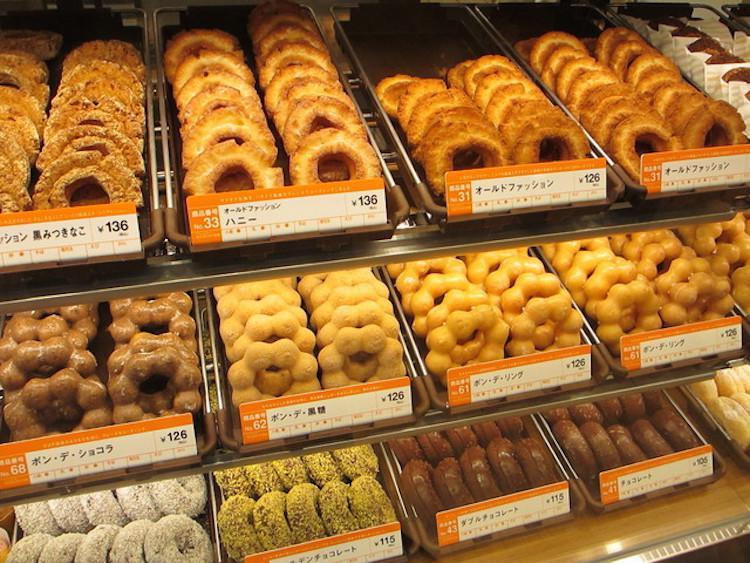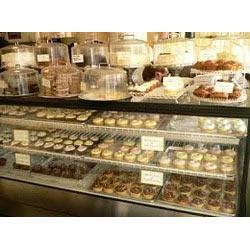The first image is the image on the left, the second image is the image on the right. Assess this claim about the two images: "At least five pendant lights hang over one of the bakery display images.". Correct or not? Answer yes or no. No. The first image is the image on the left, the second image is the image on the right. For the images displayed, is the sentence "People are standing near a case of baked goods" factually correct? Answer yes or no. No. 